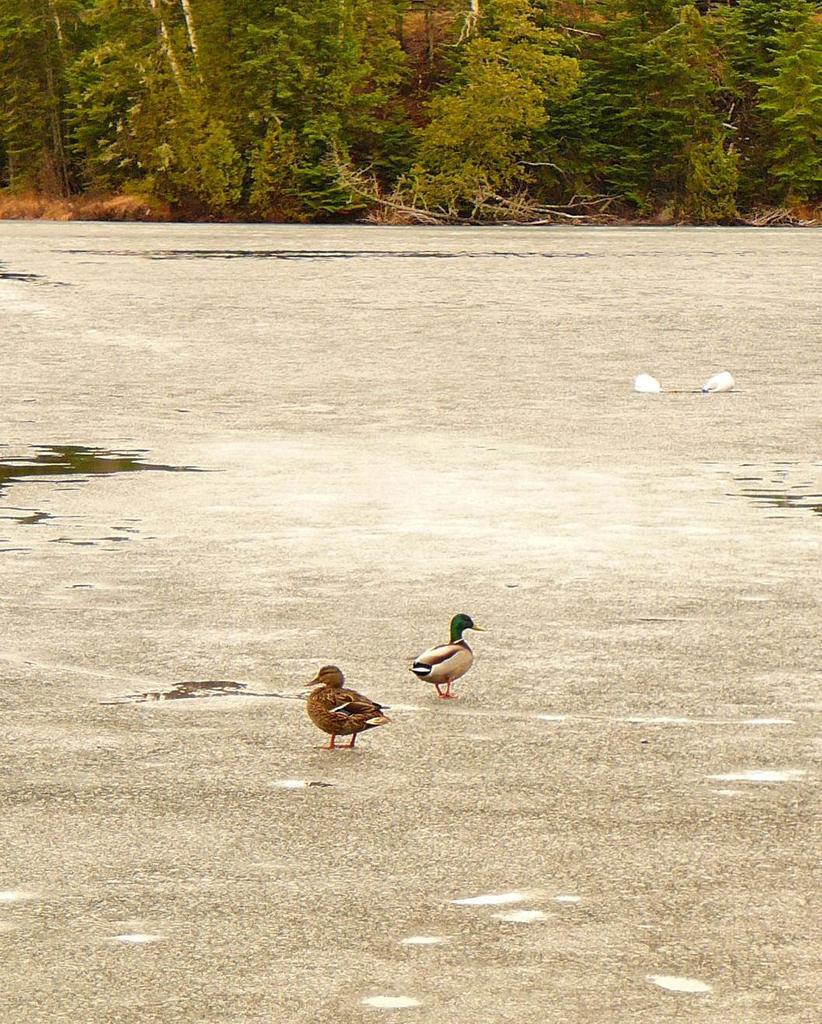Could you give a brief overview of what you see in this image? In this image, we can see the ground with some objects. There are a few birds, trees. We can see some water. 